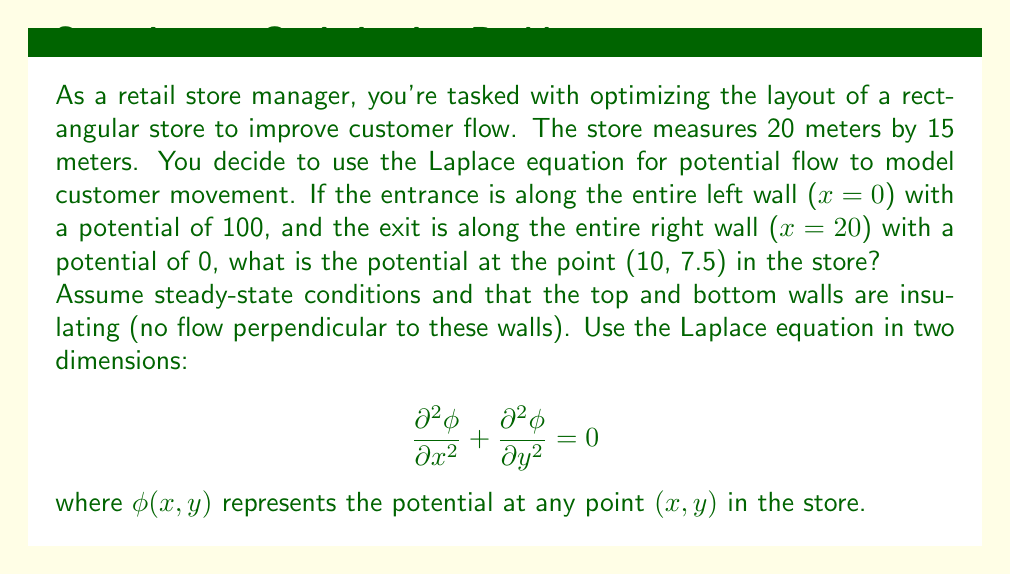Teach me how to tackle this problem. To solve this problem, we'll use the method of separation of variables for the Laplace equation.

1) First, let's define our boundary conditions:
   $\phi(0,y) = 100$ (entrance)
   $\phi(20,y) = 0$ (exit)
   $\frac{\partial \phi}{\partial y}(x,0) = \frac{\partial \phi}{\partial y}(x,15) = 0$ (insulating top and bottom walls)

2) We assume a solution of the form $\phi(x,y) = X(x)Y(y)$

3) Substituting into the Laplace equation:
   $$ X''(x)Y(y) + X(x)Y''(y) = 0 $$
   $$ \frac{X''(x)}{X(x)} = -\frac{Y''(y)}{Y(y)} = -\lambda^2 $$

4) This gives us two ODEs:
   $X''(x) + \lambda^2 X(x) = 0$
   $Y''(y) - \lambda^2 Y(y) = 0$

5) The general solutions are:
   $X(x) = A \cos(\lambda x) + B \sin(\lambda x)$
   $Y(y) = C \cosh(\lambda y) + D \sinh(\lambda y)$

6) Applying the boundary conditions for Y:
   $Y'(0) = Y'(15) = 0$ implies $D = 0$ and $\lambda = \frac{n\pi}{15}$ where $n = 0,1,2,...$

7) For X, we have:
   $X(0) = 100$ and $X(20) = 0$
   This gives us: $A = 100$ and $\tan(20\lambda) = -\infty$
   The smallest non-zero value satisfying this is $\lambda = \frac{\pi}{40}$

8) Therefore, the solution is of the form:
   $$ \phi(x,y) = 100 \left(1 - \frac{x}{20}\right) $$

9) At the point (10, 7.5):
   $$ \phi(10, 7.5) = 100 \left(1 - \frac{10}{20}\right) = 50 $$
Answer: The potential at the point (10, 7.5) in the store is 50. 